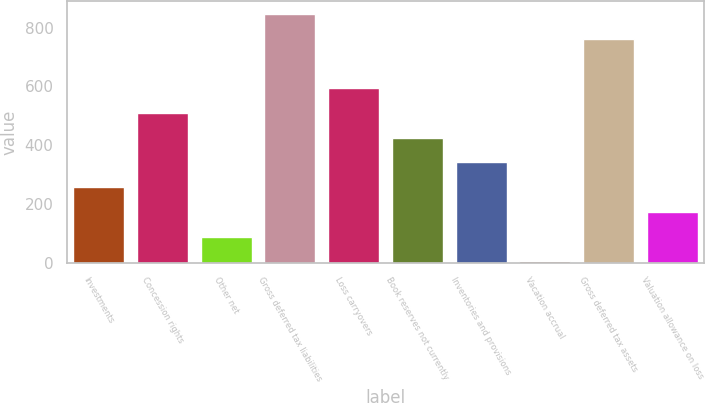Convert chart. <chart><loc_0><loc_0><loc_500><loc_500><bar_chart><fcel>Investments<fcel>Concession rights<fcel>Other net<fcel>Gross deferred tax liabilities<fcel>Loss carryovers<fcel>Book reserves not currently<fcel>Inventories and provisions<fcel>Vacation accrual<fcel>Gross deferred tax assets<fcel>Valuation allowance on loss<nl><fcel>256.73<fcel>509.66<fcel>88.11<fcel>846.9<fcel>593.97<fcel>425.35<fcel>341.04<fcel>3.8<fcel>762.59<fcel>172.42<nl></chart> 